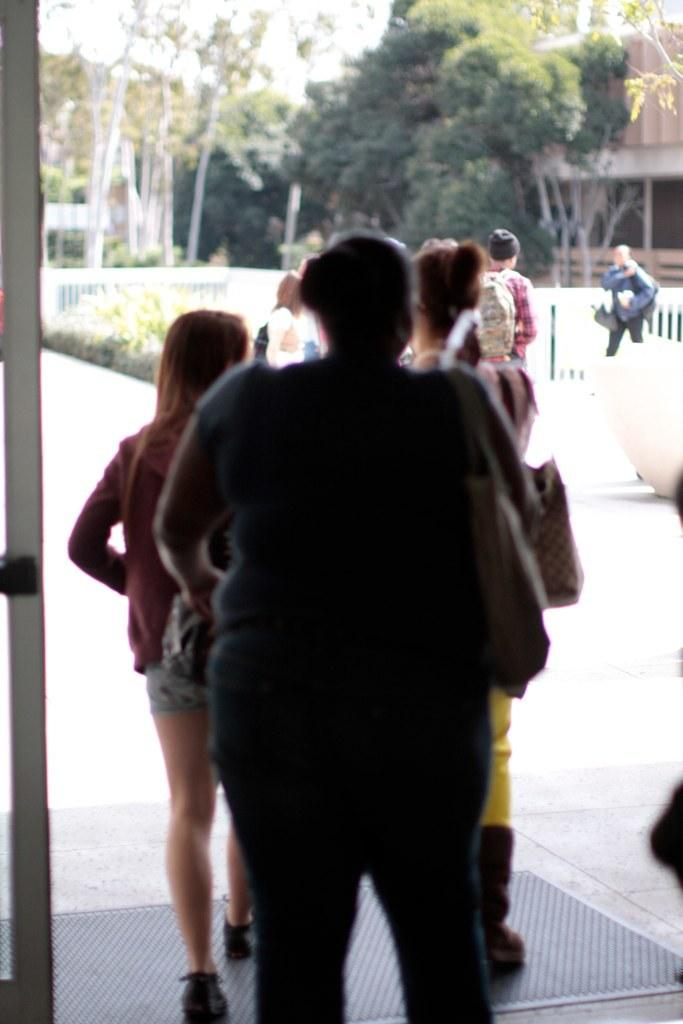How many people are in the image? There is a group of people in the image, but the exact number cannot be determined from the provided facts. What are some of the people in the image doing? Some people are standing, and some are walking. What can be seen in the background of the image? There are trees, houses, plants, and railings in the background of the image. What type of lipstick is the person wearing in the image? There is no mention of lipstick or any person wearing lipstick in the image. What kind of fuel is being used by the vehicles in the image? There are no vehicles present in the image, so it is not possible to determine what kind of fuel they might be using. 